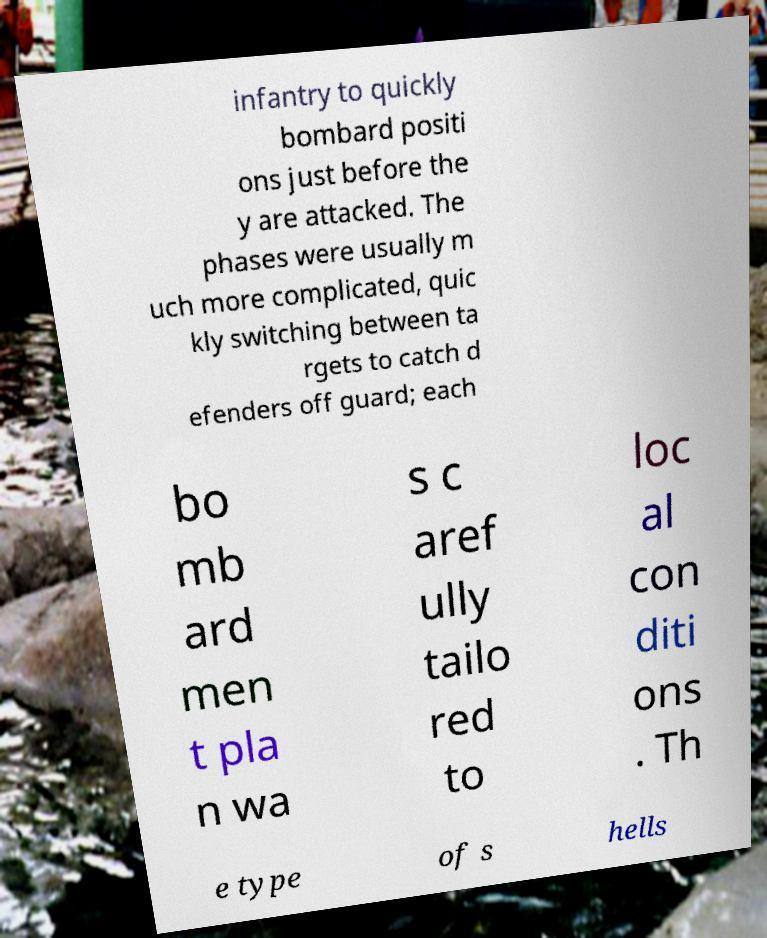What messages or text are displayed in this image? I need them in a readable, typed format. infantry to quickly bombard positi ons just before the y are attacked. The phases were usually m uch more complicated, quic kly switching between ta rgets to catch d efenders off guard; each bo mb ard men t pla n wa s c aref ully tailo red to loc al con diti ons . Th e type of s hells 